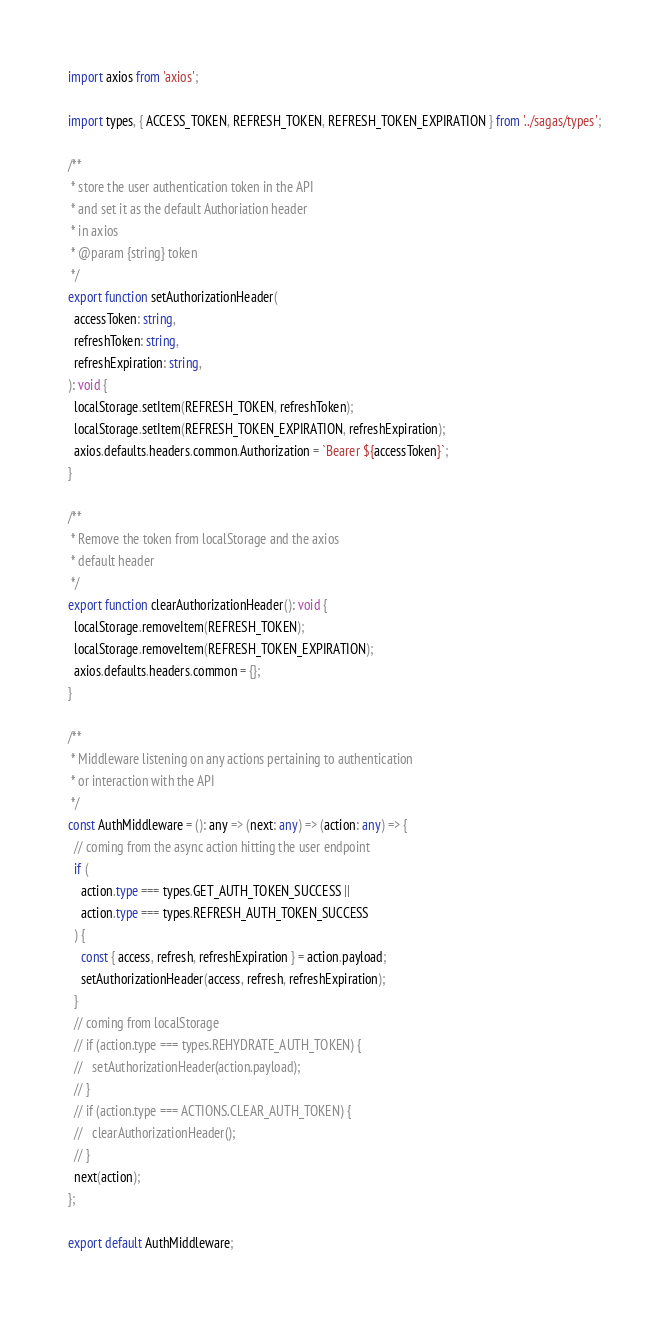Convert code to text. <code><loc_0><loc_0><loc_500><loc_500><_TypeScript_>import axios from 'axios';

import types, { ACCESS_TOKEN, REFRESH_TOKEN, REFRESH_TOKEN_EXPIRATION } from '../sagas/types';

/**
 * store the user authentication token in the API
 * and set it as the default Authoriation header
 * in axios
 * @param {string} token
 */
export function setAuthorizationHeader(
  accessToken: string,
  refreshToken: string,
  refreshExpiration: string,
): void {
  localStorage.setItem(REFRESH_TOKEN, refreshToken);
  localStorage.setItem(REFRESH_TOKEN_EXPIRATION, refreshExpiration);
  axios.defaults.headers.common.Authorization = `Bearer ${accessToken}`;
}

/**
 * Remove the token from localStorage and the axios
 * default header
 */
export function clearAuthorizationHeader(): void {
  localStorage.removeItem(REFRESH_TOKEN);
  localStorage.removeItem(REFRESH_TOKEN_EXPIRATION);
  axios.defaults.headers.common = {};
}

/**
 * Middleware listening on any actions pertaining to authentication
 * or interaction with the API
 */
const AuthMiddleware = (): any => (next: any) => (action: any) => {
  // coming from the async action hitting the user endpoint
  if (
    action.type === types.GET_AUTH_TOKEN_SUCCESS ||
    action.type === types.REFRESH_AUTH_TOKEN_SUCCESS
  ) {
    const { access, refresh, refreshExpiration } = action.payload;
    setAuthorizationHeader(access, refresh, refreshExpiration);
  }
  // coming from localStorage
  // if (action.type === types.REHYDRATE_AUTH_TOKEN) {
  //   setAuthorizationHeader(action.payload);
  // }
  // if (action.type === ACTIONS.CLEAR_AUTH_TOKEN) {
  //   clearAuthorizationHeader();
  // }
  next(action);
};

export default AuthMiddleware;
</code> 